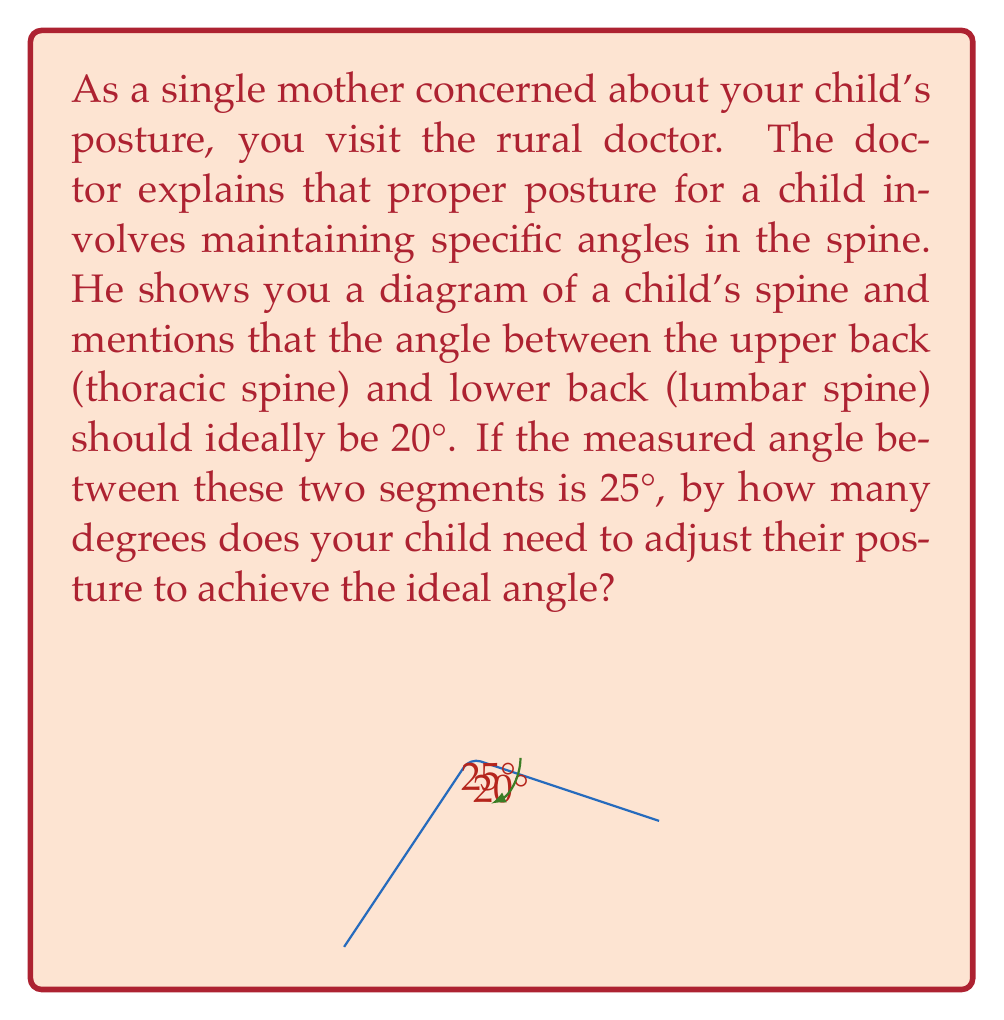Solve this math problem. To solve this problem, we need to understand the concept of angle difference. The goal is to find how much the current angle needs to be reduced to reach the ideal angle.

Given:
- Ideal angle between thoracic and lumbar spine: 20°
- Measured angle: 25°

To find the adjustment needed:
1. Calculate the difference between the measured angle and the ideal angle.
2. Use the formula: Adjustment = Measured angle - Ideal angle

$$\text{Adjustment} = 25° - 20°$$
$$\text{Adjustment} = 5°$$

Therefore, your child needs to reduce the angle between their upper and lower back by 5° to achieve the ideal posture according to the doctor's recommendation.
Answer: $5°$ 